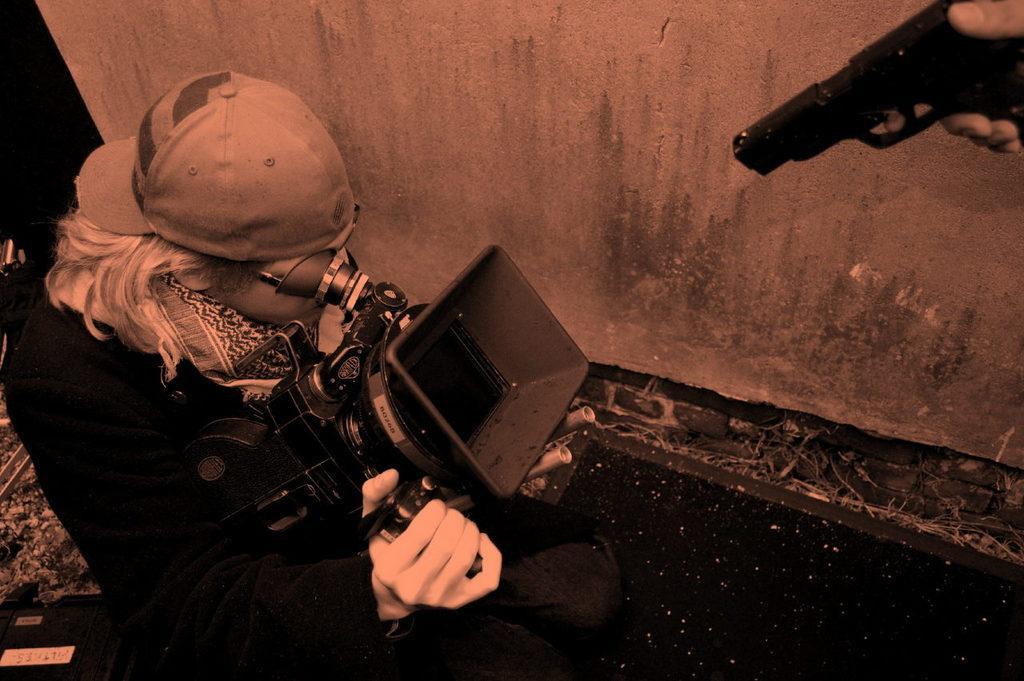Describe this image in one or two sentences. In the center of the image we can see a person is sitting and she is holding a camera. On the left side of the image, we can see some objects. At the top right side of the image, we can see the fingers of a person is holding a gun. In the background there is a wall. 